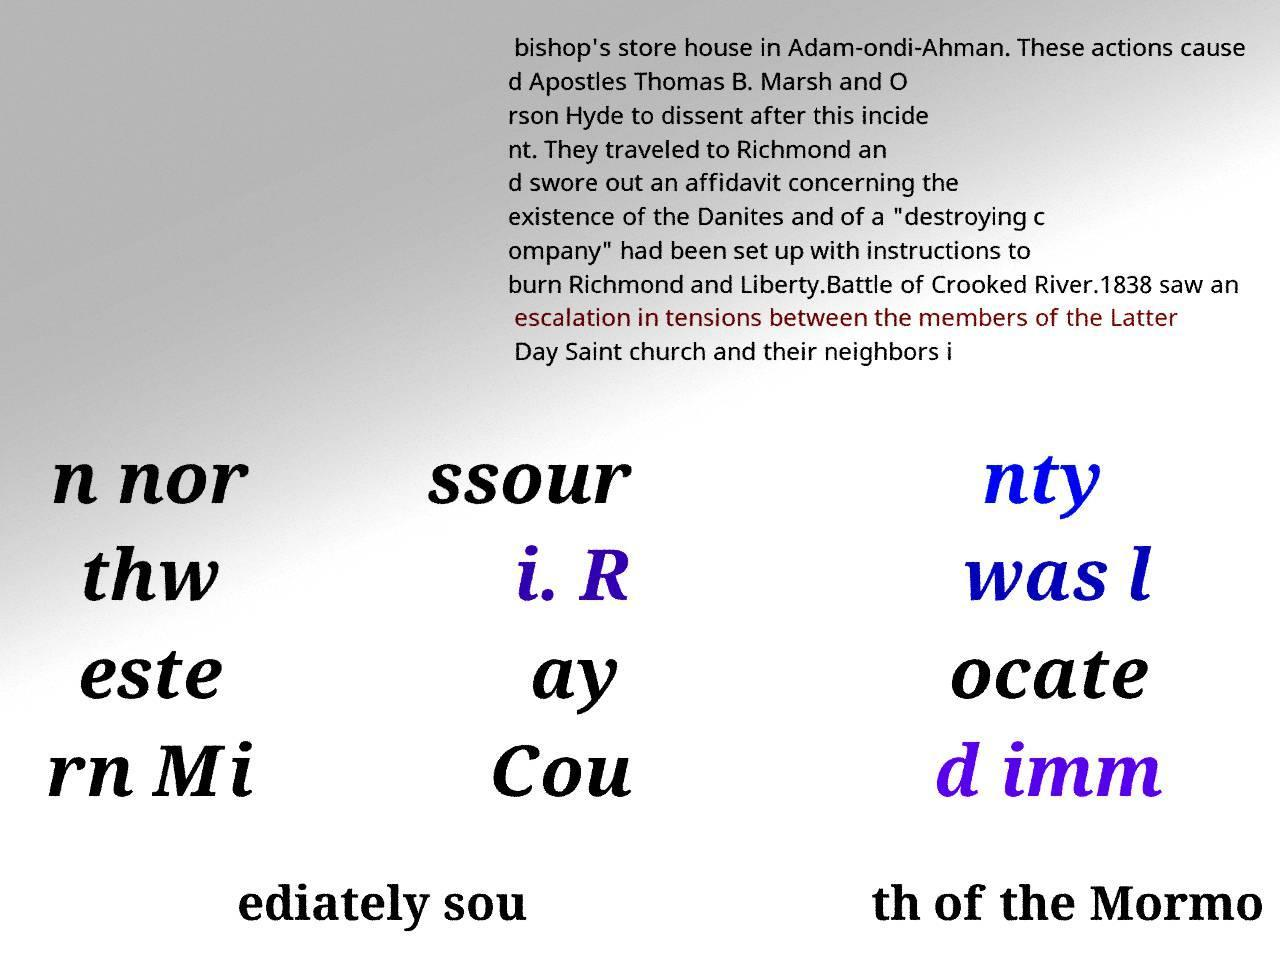There's text embedded in this image that I need extracted. Can you transcribe it verbatim? bishop's store house in Adam-ondi-Ahman. These actions cause d Apostles Thomas B. Marsh and O rson Hyde to dissent after this incide nt. They traveled to Richmond an d swore out an affidavit concerning the existence of the Danites and of a "destroying c ompany" had been set up with instructions to burn Richmond and Liberty.Battle of Crooked River.1838 saw an escalation in tensions between the members of the Latter Day Saint church and their neighbors i n nor thw este rn Mi ssour i. R ay Cou nty was l ocate d imm ediately sou th of the Mormo 